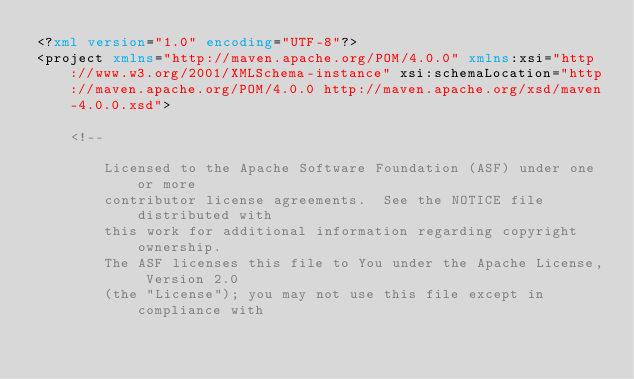Convert code to text. <code><loc_0><loc_0><loc_500><loc_500><_XML_><?xml version="1.0" encoding="UTF-8"?>
<project xmlns="http://maven.apache.org/POM/4.0.0" xmlns:xsi="http://www.w3.org/2001/XMLSchema-instance" xsi:schemaLocation="http://maven.apache.org/POM/4.0.0 http://maven.apache.org/xsd/maven-4.0.0.xsd">

    <!--

        Licensed to the Apache Software Foundation (ASF) under one or more
        contributor license agreements.  See the NOTICE file distributed with
        this work for additional information regarding copyright ownership.
        The ASF licenses this file to You under the Apache License, Version 2.0
        (the "License"); you may not use this file except in compliance with</code> 